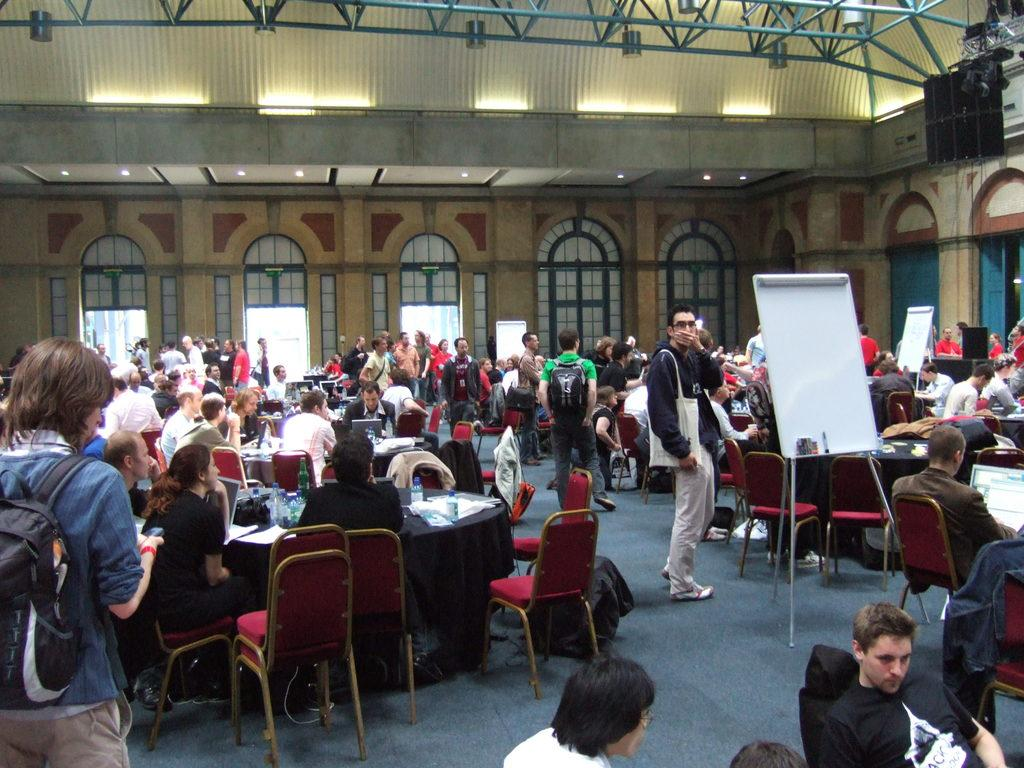What is the main subject in the middle of the image? There is a man standing in the middle of the image. What are the other people in the image doing? There is a group of people sitting around chairs in the image. What type of hat is the mom wearing in the image? There is no mom or hat present in the image. 